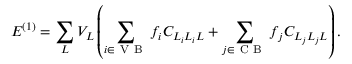Convert formula to latex. <formula><loc_0><loc_0><loc_500><loc_500>E ^ { ( 1 ) } = \sum _ { L } V _ { L } \left ( \sum _ { i \in V B } f _ { i } C _ { L _ { i } L _ { i } L } + \sum _ { j \in C B } f _ { j } C _ { L _ { j } L _ { j } L } \right ) .</formula> 